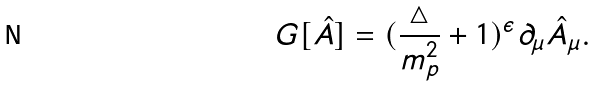Convert formula to latex. <formula><loc_0><loc_0><loc_500><loc_500>G [ \hat { A } ] = ( \frac { \triangle } { m ^ { 2 } _ { p } } + 1 ) ^ { \epsilon } \partial _ { \mu } \hat { A } _ { \mu } .</formula> 